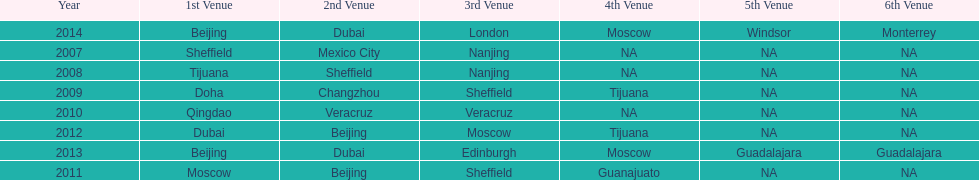How long, in years, has the this world series been occurring? 7 years. 